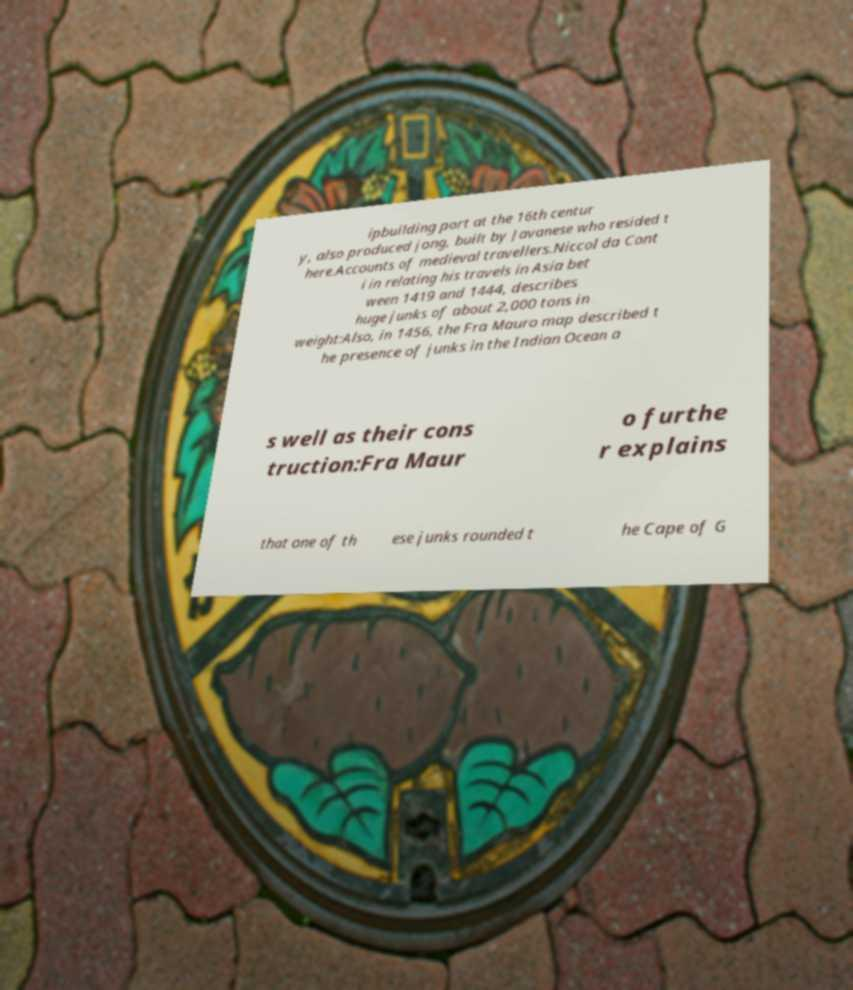There's text embedded in this image that I need extracted. Can you transcribe it verbatim? ipbuilding port at the 16th centur y, also produced jong, built by Javanese who resided t here.Accounts of medieval travellers.Niccol da Cont i in relating his travels in Asia bet ween 1419 and 1444, describes huge junks of about 2,000 tons in weight:Also, in 1456, the Fra Mauro map described t he presence of junks in the Indian Ocean a s well as their cons truction:Fra Maur o furthe r explains that one of th ese junks rounded t he Cape of G 